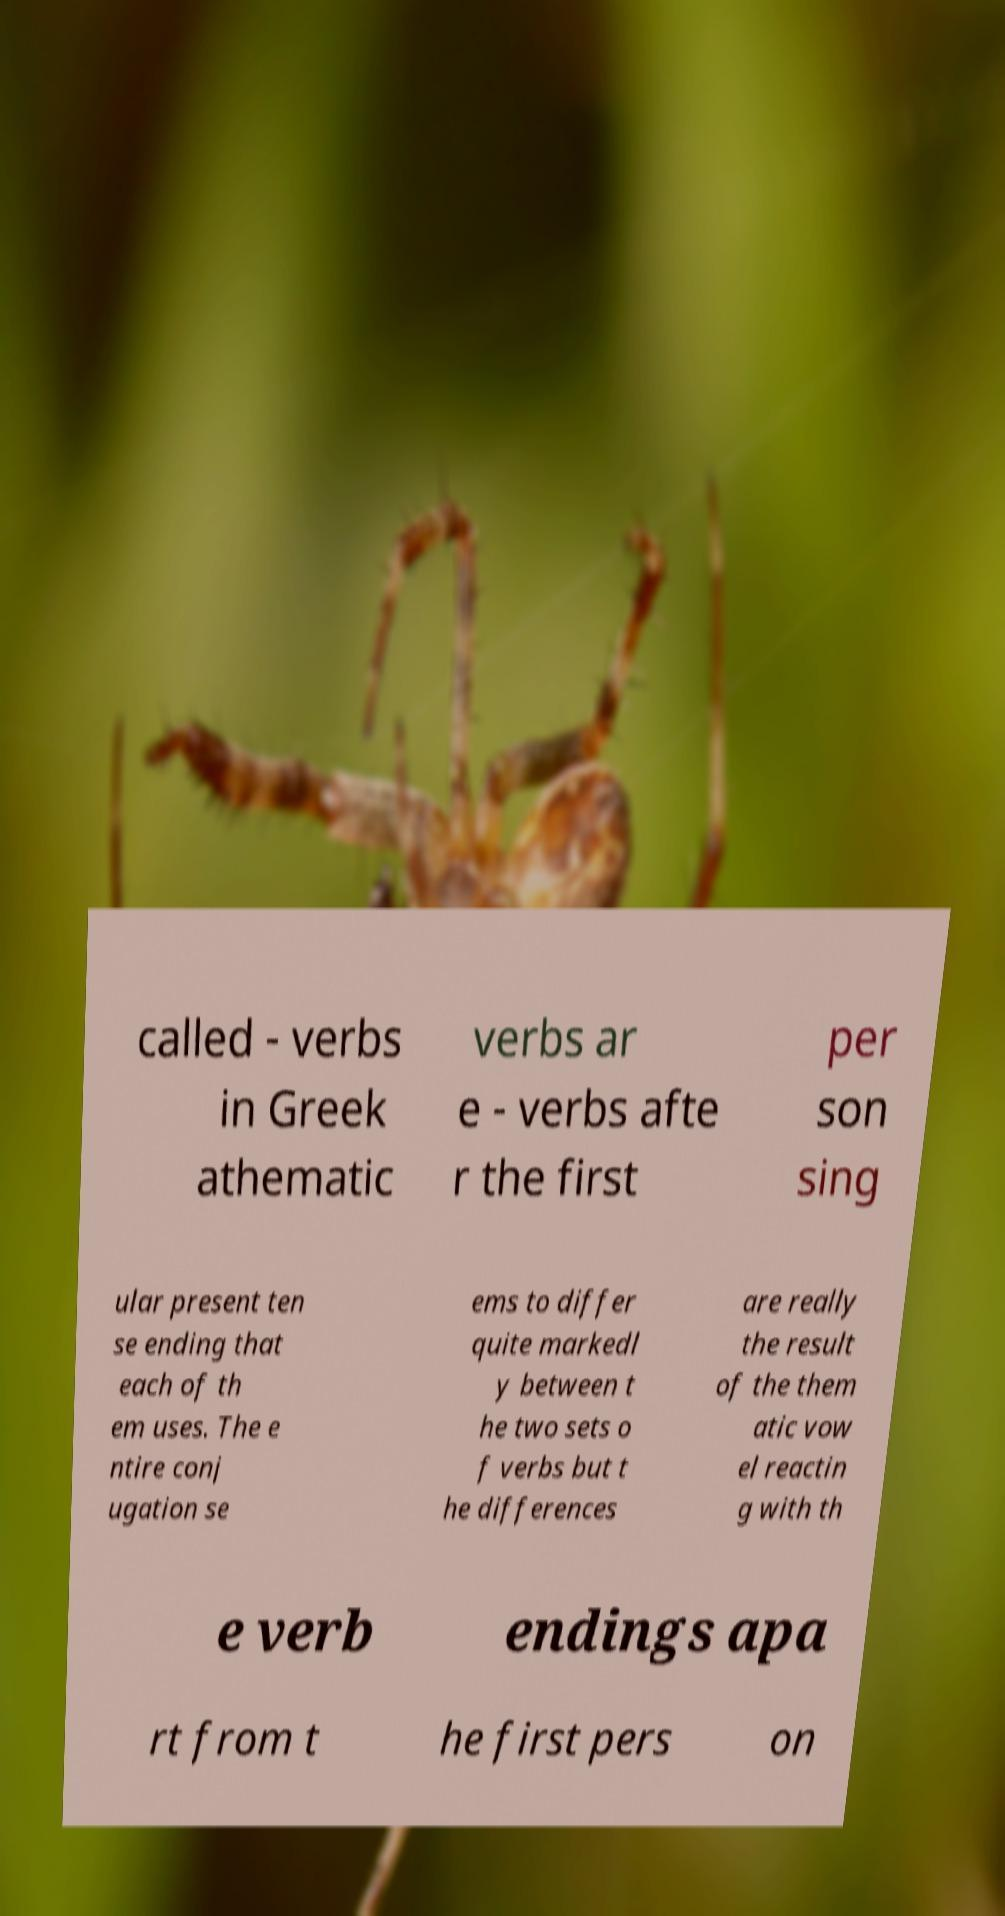I need the written content from this picture converted into text. Can you do that? called - verbs in Greek athematic verbs ar e - verbs afte r the first per son sing ular present ten se ending that each of th em uses. The e ntire conj ugation se ems to differ quite markedl y between t he two sets o f verbs but t he differences are really the result of the them atic vow el reactin g with th e verb endings apa rt from t he first pers on 